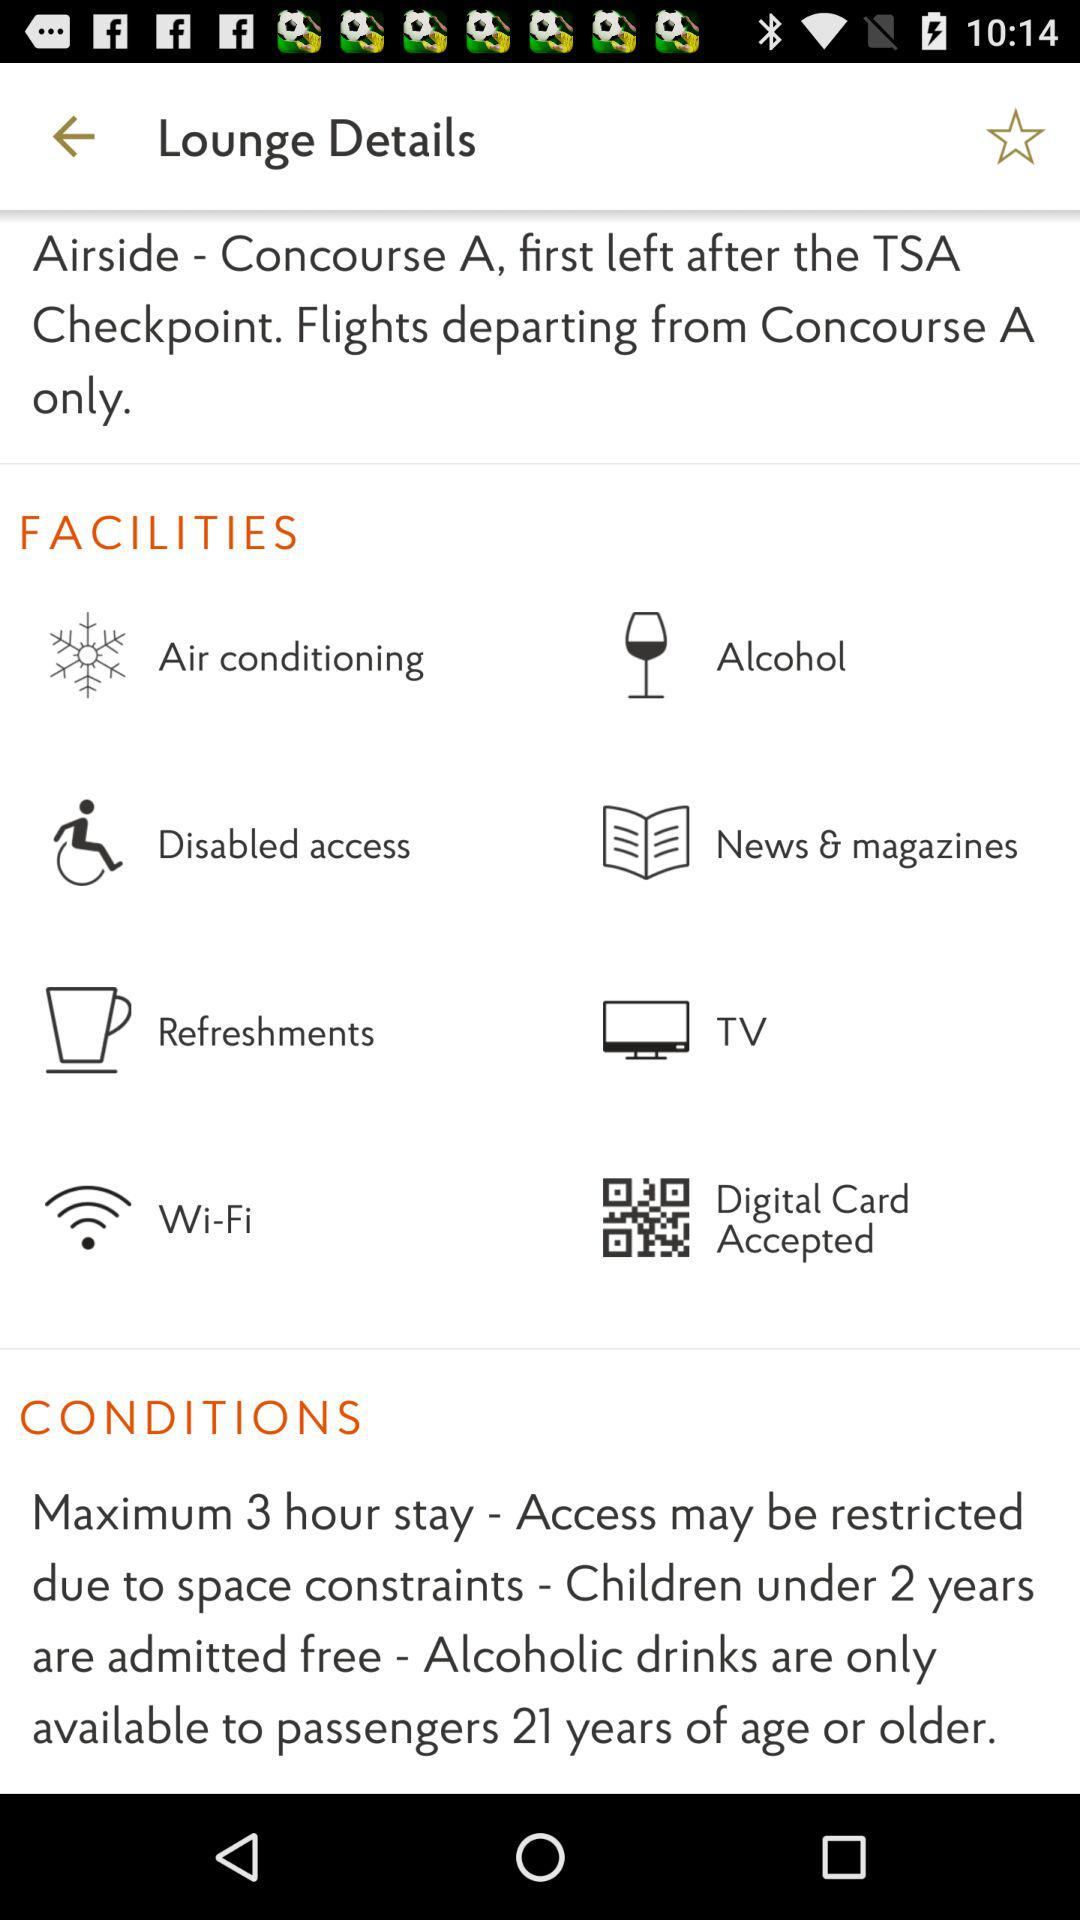How many conditions are there in the lounge?
Answer the question using a single word or phrase. 4 